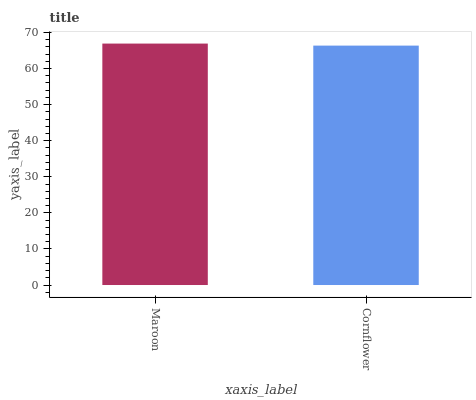Is Cornflower the minimum?
Answer yes or no. Yes. Is Maroon the maximum?
Answer yes or no. Yes. Is Cornflower the maximum?
Answer yes or no. No. Is Maroon greater than Cornflower?
Answer yes or no. Yes. Is Cornflower less than Maroon?
Answer yes or no. Yes. Is Cornflower greater than Maroon?
Answer yes or no. No. Is Maroon less than Cornflower?
Answer yes or no. No. Is Maroon the high median?
Answer yes or no. Yes. Is Cornflower the low median?
Answer yes or no. Yes. Is Cornflower the high median?
Answer yes or no. No. Is Maroon the low median?
Answer yes or no. No. 